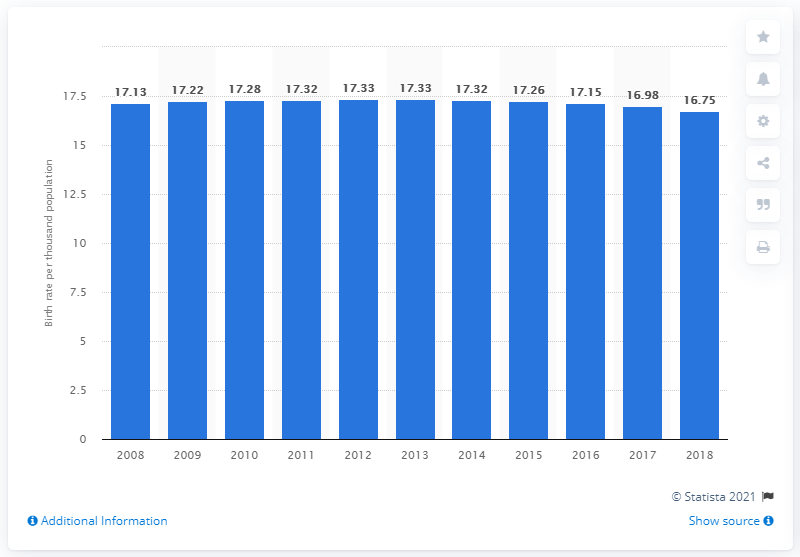Indicate a few pertinent items in this graphic. The crude birth rate in Vietnam in 2018 was 16.75. 